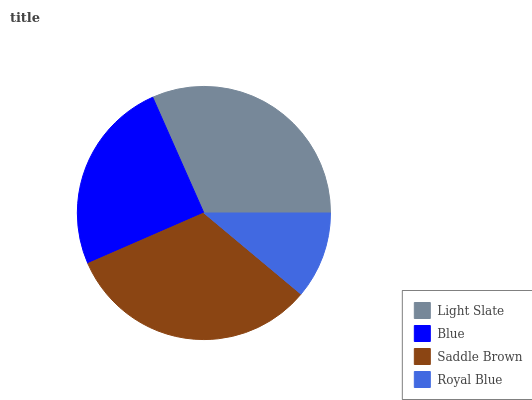Is Royal Blue the minimum?
Answer yes or no. Yes. Is Saddle Brown the maximum?
Answer yes or no. Yes. Is Blue the minimum?
Answer yes or no. No. Is Blue the maximum?
Answer yes or no. No. Is Light Slate greater than Blue?
Answer yes or no. Yes. Is Blue less than Light Slate?
Answer yes or no. Yes. Is Blue greater than Light Slate?
Answer yes or no. No. Is Light Slate less than Blue?
Answer yes or no. No. Is Light Slate the high median?
Answer yes or no. Yes. Is Blue the low median?
Answer yes or no. Yes. Is Blue the high median?
Answer yes or no. No. Is Royal Blue the low median?
Answer yes or no. No. 